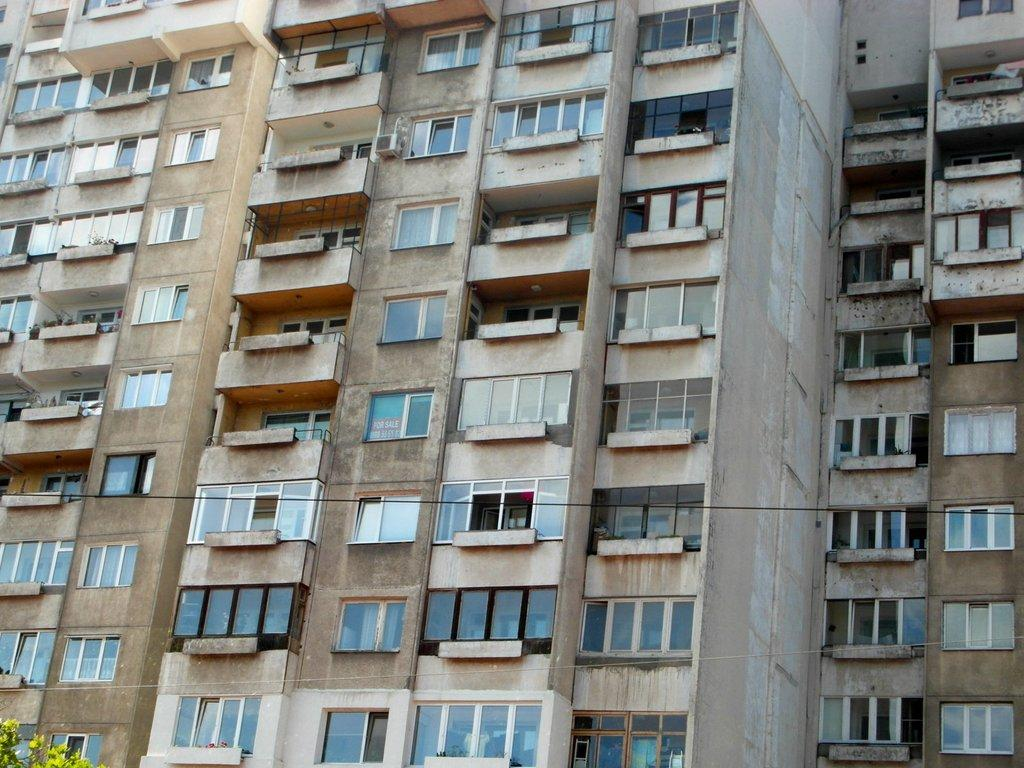What type of structure is visible in the image? There is a building in the image. What feature can be seen on the building? The building has windows. Where is the building located in the image? The building is located in the center of the image. What type of spoon is being used to care for the deceased in the image? There is no spoon or reference to death in the image; it only features a building with windows. 